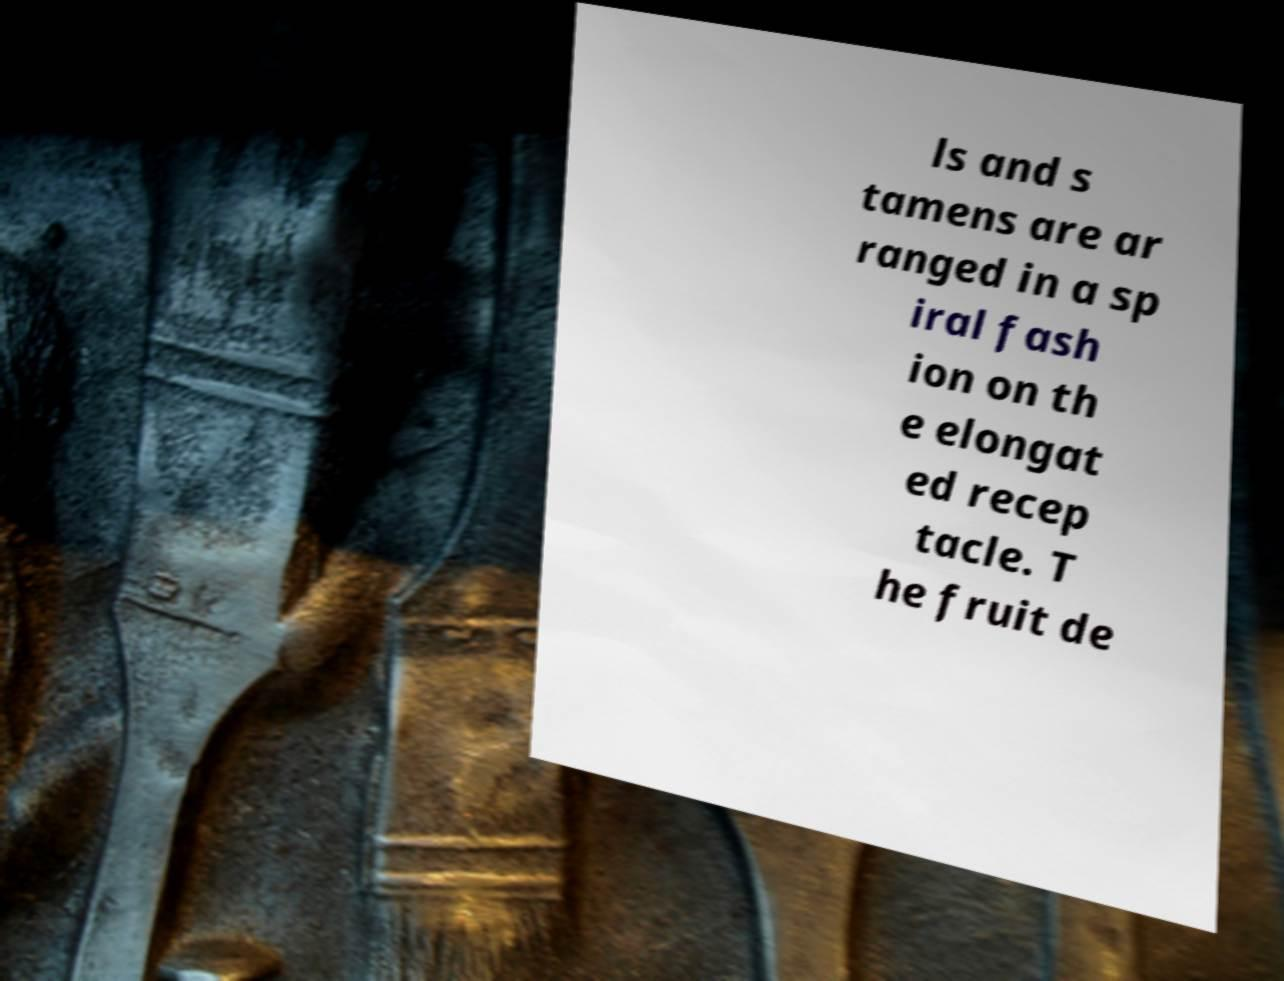Could you assist in decoding the text presented in this image and type it out clearly? ls and s tamens are ar ranged in a sp iral fash ion on th e elongat ed recep tacle. T he fruit de 